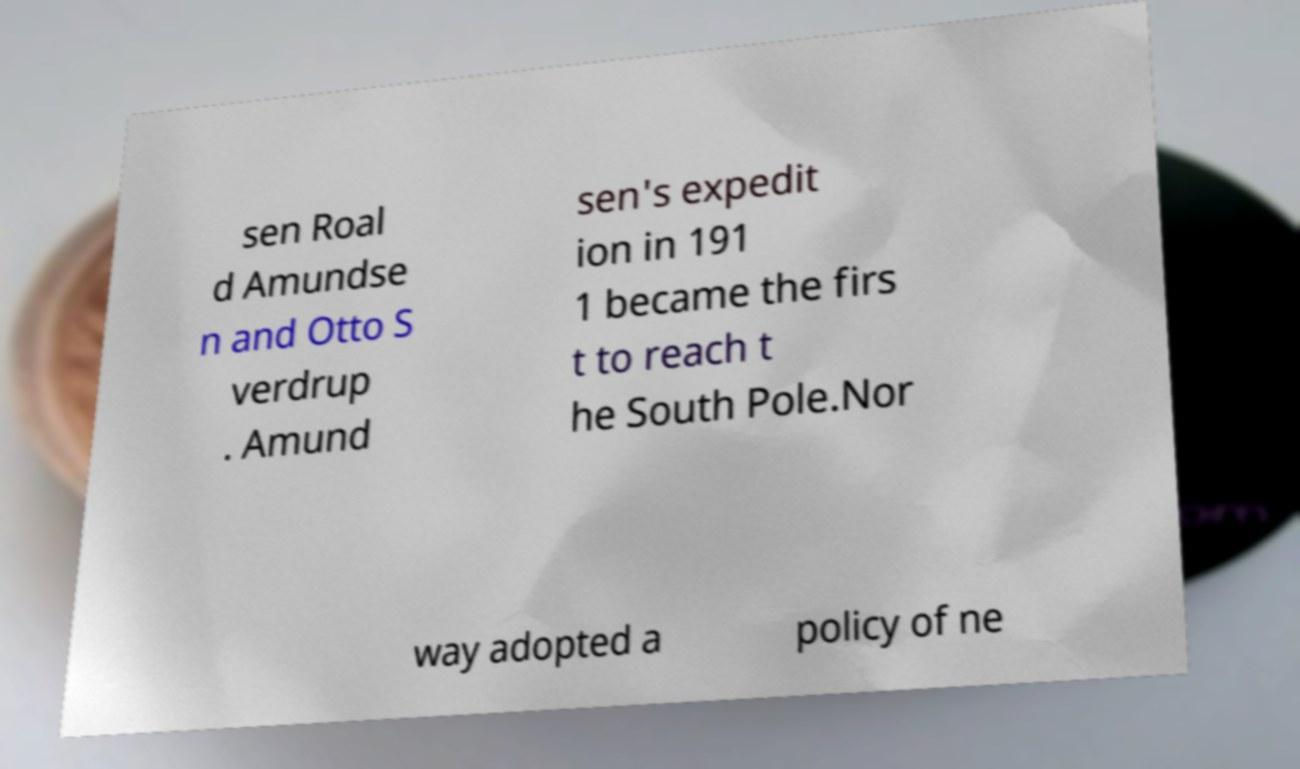There's text embedded in this image that I need extracted. Can you transcribe it verbatim? sen Roal d Amundse n and Otto S verdrup . Amund sen's expedit ion in 191 1 became the firs t to reach t he South Pole.Nor way adopted a policy of ne 